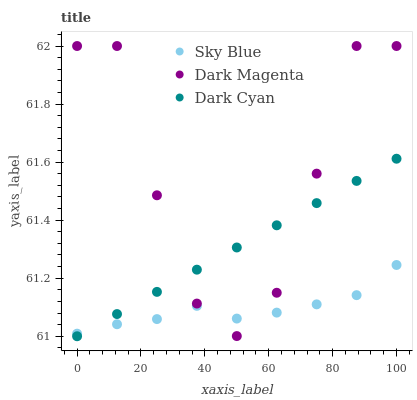Does Sky Blue have the minimum area under the curve?
Answer yes or no. Yes. Does Dark Magenta have the maximum area under the curve?
Answer yes or no. Yes. Does Dark Magenta have the minimum area under the curve?
Answer yes or no. No. Does Sky Blue have the maximum area under the curve?
Answer yes or no. No. Is Dark Cyan the smoothest?
Answer yes or no. Yes. Is Dark Magenta the roughest?
Answer yes or no. Yes. Is Sky Blue the smoothest?
Answer yes or no. No. Is Sky Blue the roughest?
Answer yes or no. No. Does Dark Cyan have the lowest value?
Answer yes or no. Yes. Does Dark Magenta have the lowest value?
Answer yes or no. No. Does Dark Magenta have the highest value?
Answer yes or no. Yes. Does Sky Blue have the highest value?
Answer yes or no. No. Does Dark Cyan intersect Sky Blue?
Answer yes or no. Yes. Is Dark Cyan less than Sky Blue?
Answer yes or no. No. Is Dark Cyan greater than Sky Blue?
Answer yes or no. No. 